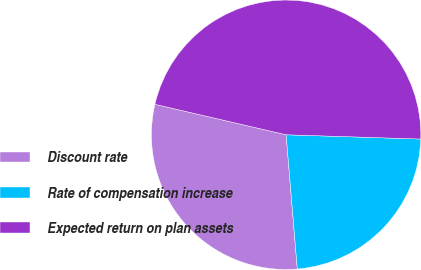<chart> <loc_0><loc_0><loc_500><loc_500><pie_chart><fcel>Discount rate<fcel>Rate of compensation increase<fcel>Expected return on plan assets<nl><fcel>29.95%<fcel>23.17%<fcel>46.87%<nl></chart> 